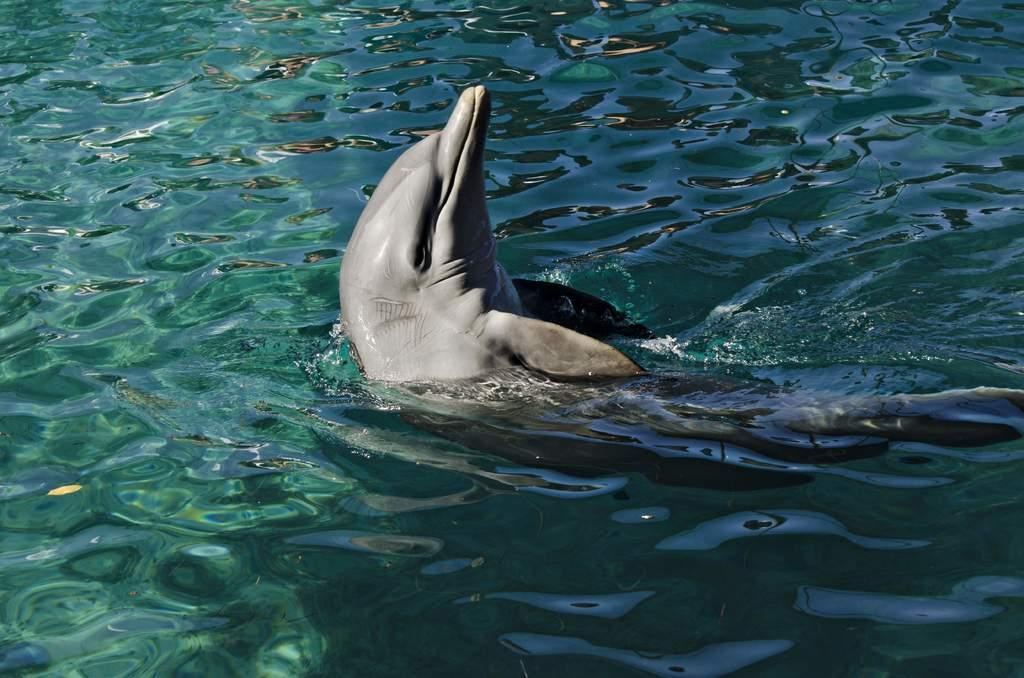What is the main subject of the image? There is a dolphin in the center of the image. Where is the dolphin located? The dolphin is in the water. What can be seen around the area of the image? There is water visible around the area of the image. What type of beef is being used to feed the bird in the image? There is no beef or bird present in the image; it features a dolphin in the water. 